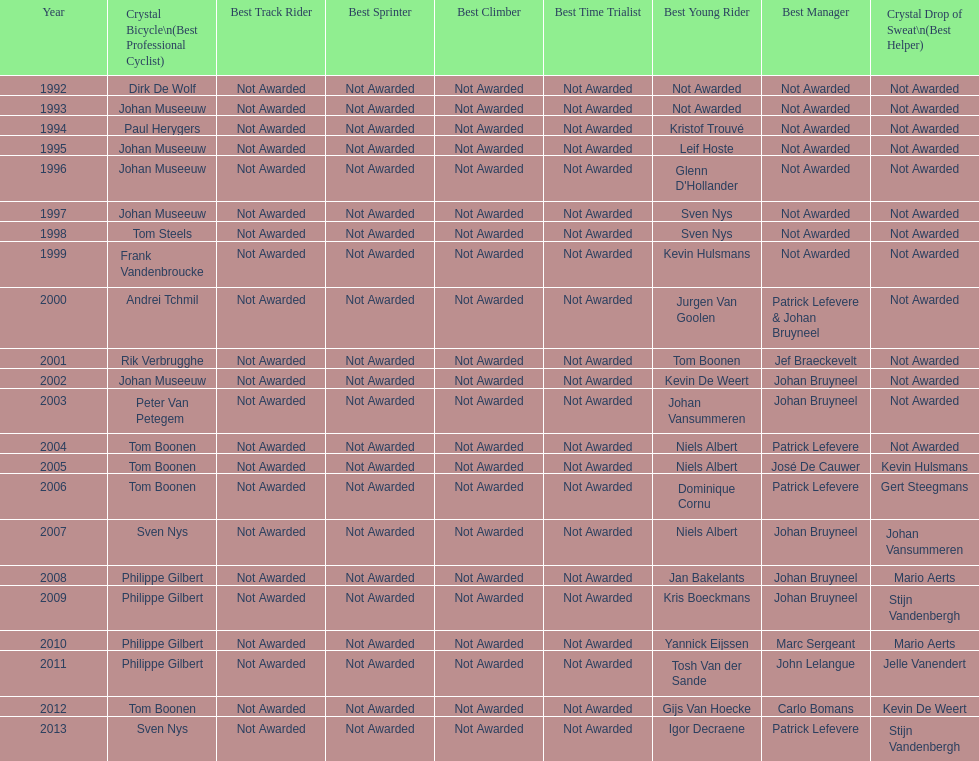Who holds the record for the most uninterrupted triumphs in crystal bicycle competitions? Philippe Gilbert. 